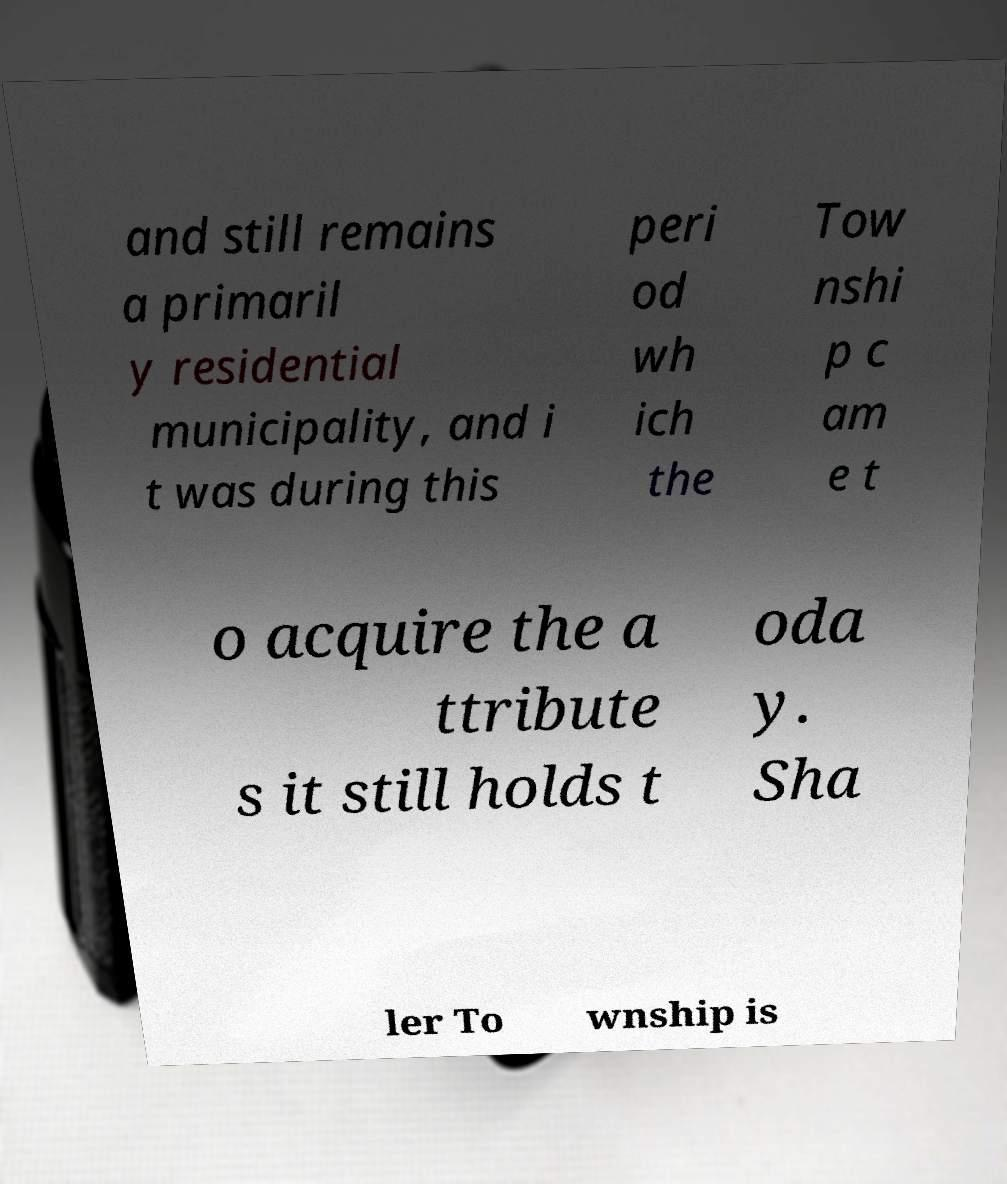Please read and relay the text visible in this image. What does it say? and still remains a primaril y residential municipality, and i t was during this peri od wh ich the Tow nshi p c am e t o acquire the a ttribute s it still holds t oda y. Sha ler To wnship is 